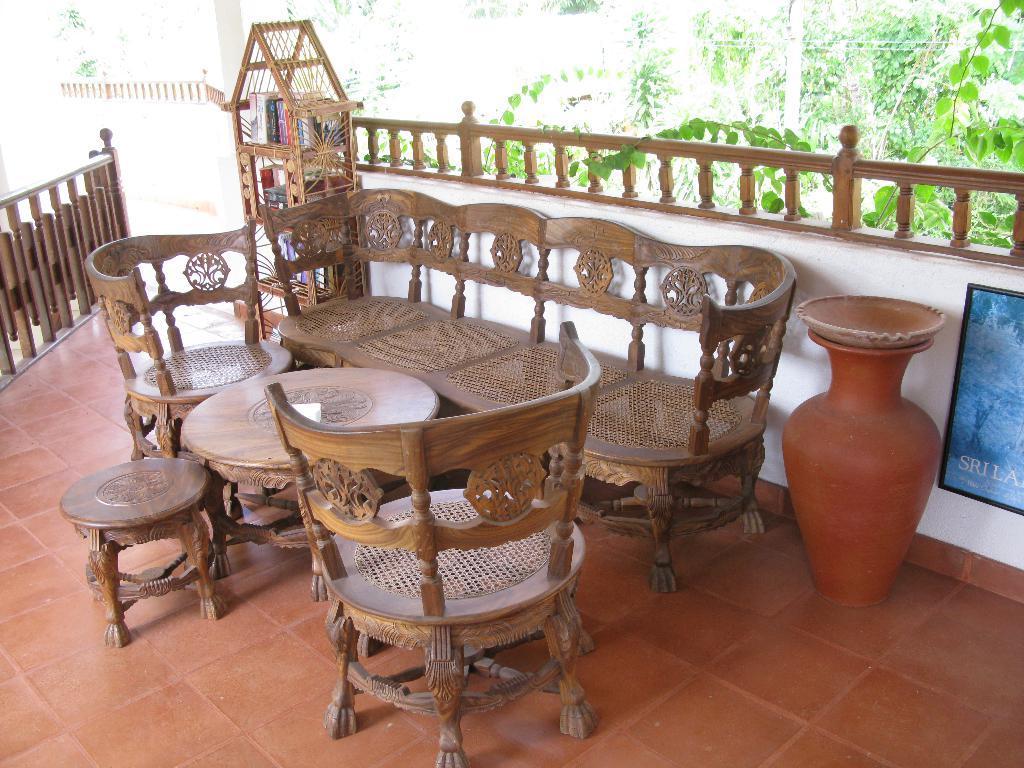Describe this image in one or two sentences. In this image we can see wooden sofa, chairs and table. There is a flower pot and wooden cupboard with books. In the background we can see trees. 